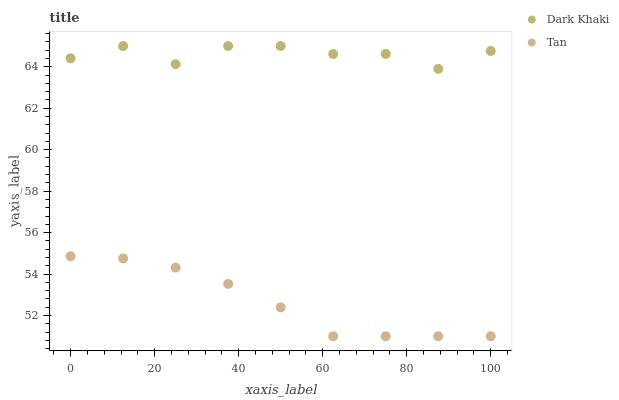Does Tan have the minimum area under the curve?
Answer yes or no. Yes. Does Dark Khaki have the maximum area under the curve?
Answer yes or no. Yes. Does Tan have the maximum area under the curve?
Answer yes or no. No. Is Tan the smoothest?
Answer yes or no. Yes. Is Dark Khaki the roughest?
Answer yes or no. Yes. Is Tan the roughest?
Answer yes or no. No. Does Tan have the lowest value?
Answer yes or no. Yes. Does Dark Khaki have the highest value?
Answer yes or no. Yes. Does Tan have the highest value?
Answer yes or no. No. Is Tan less than Dark Khaki?
Answer yes or no. Yes. Is Dark Khaki greater than Tan?
Answer yes or no. Yes. Does Tan intersect Dark Khaki?
Answer yes or no. No. 